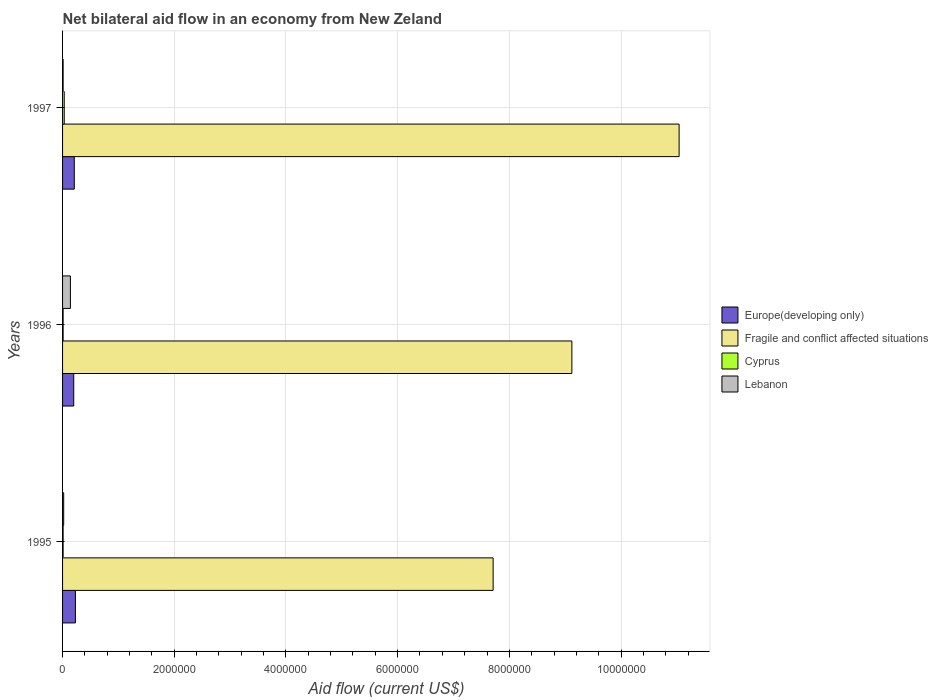How many different coloured bars are there?
Offer a very short reply. 4. Are the number of bars per tick equal to the number of legend labels?
Provide a succinct answer. Yes. Are the number of bars on each tick of the Y-axis equal?
Offer a terse response. Yes. How many bars are there on the 2nd tick from the bottom?
Your answer should be compact. 4. What is the label of the 3rd group of bars from the top?
Keep it short and to the point. 1995. Across all years, what is the maximum net bilateral aid flow in Lebanon?
Offer a very short reply. 1.40e+05. Across all years, what is the minimum net bilateral aid flow in Europe(developing only)?
Your answer should be very brief. 2.00e+05. In which year was the net bilateral aid flow in Europe(developing only) minimum?
Give a very brief answer. 1996. What is the total net bilateral aid flow in Europe(developing only) in the graph?
Your answer should be very brief. 6.40e+05. What is the difference between the net bilateral aid flow in Fragile and conflict affected situations in 1995 and that in 1996?
Provide a short and direct response. -1.41e+06. What is the difference between the net bilateral aid flow in Cyprus in 1996 and the net bilateral aid flow in Fragile and conflict affected situations in 1997?
Provide a succinct answer. -1.10e+07. What is the average net bilateral aid flow in Cyprus per year?
Make the answer very short. 1.67e+04. In the year 1997, what is the difference between the net bilateral aid flow in Cyprus and net bilateral aid flow in Lebanon?
Your answer should be very brief. 2.00e+04. What is the ratio of the net bilateral aid flow in Cyprus in 1995 to that in 1996?
Your answer should be compact. 1. Is the difference between the net bilateral aid flow in Cyprus in 1995 and 1996 greater than the difference between the net bilateral aid flow in Lebanon in 1995 and 1996?
Keep it short and to the point. Yes. What is the difference between the highest and the lowest net bilateral aid flow in Lebanon?
Offer a terse response. 1.30e+05. Is the sum of the net bilateral aid flow in Cyprus in 1996 and 1997 greater than the maximum net bilateral aid flow in Fragile and conflict affected situations across all years?
Your answer should be compact. No. Is it the case that in every year, the sum of the net bilateral aid flow in Lebanon and net bilateral aid flow in Europe(developing only) is greater than the sum of net bilateral aid flow in Cyprus and net bilateral aid flow in Fragile and conflict affected situations?
Your answer should be compact. Yes. What does the 2nd bar from the top in 1995 represents?
Your answer should be very brief. Cyprus. What does the 1st bar from the bottom in 1995 represents?
Provide a succinct answer. Europe(developing only). How many years are there in the graph?
Provide a short and direct response. 3. What is the difference between two consecutive major ticks on the X-axis?
Your response must be concise. 2.00e+06. Does the graph contain any zero values?
Your answer should be very brief. No. How are the legend labels stacked?
Offer a terse response. Vertical. What is the title of the graph?
Keep it short and to the point. Net bilateral aid flow in an economy from New Zeland. What is the label or title of the Y-axis?
Provide a short and direct response. Years. What is the Aid flow (current US$) of Fragile and conflict affected situations in 1995?
Keep it short and to the point. 7.71e+06. What is the Aid flow (current US$) in Lebanon in 1995?
Ensure brevity in your answer.  2.00e+04. What is the Aid flow (current US$) of Europe(developing only) in 1996?
Make the answer very short. 2.00e+05. What is the Aid flow (current US$) of Fragile and conflict affected situations in 1996?
Your answer should be compact. 9.12e+06. What is the Aid flow (current US$) of Fragile and conflict affected situations in 1997?
Your response must be concise. 1.10e+07. What is the Aid flow (current US$) in Lebanon in 1997?
Offer a terse response. 10000. Across all years, what is the maximum Aid flow (current US$) of Europe(developing only)?
Give a very brief answer. 2.30e+05. Across all years, what is the maximum Aid flow (current US$) in Fragile and conflict affected situations?
Offer a terse response. 1.10e+07. Across all years, what is the maximum Aid flow (current US$) of Lebanon?
Give a very brief answer. 1.40e+05. Across all years, what is the minimum Aid flow (current US$) of Fragile and conflict affected situations?
Provide a succinct answer. 7.71e+06. Across all years, what is the minimum Aid flow (current US$) in Cyprus?
Offer a very short reply. 10000. What is the total Aid flow (current US$) of Europe(developing only) in the graph?
Keep it short and to the point. 6.40e+05. What is the total Aid flow (current US$) of Fragile and conflict affected situations in the graph?
Your answer should be compact. 2.79e+07. What is the total Aid flow (current US$) in Cyprus in the graph?
Ensure brevity in your answer.  5.00e+04. What is the total Aid flow (current US$) in Lebanon in the graph?
Your answer should be compact. 1.70e+05. What is the difference between the Aid flow (current US$) in Fragile and conflict affected situations in 1995 and that in 1996?
Provide a succinct answer. -1.41e+06. What is the difference between the Aid flow (current US$) in Europe(developing only) in 1995 and that in 1997?
Your answer should be very brief. 2.00e+04. What is the difference between the Aid flow (current US$) in Fragile and conflict affected situations in 1995 and that in 1997?
Provide a succinct answer. -3.33e+06. What is the difference between the Aid flow (current US$) in Cyprus in 1995 and that in 1997?
Make the answer very short. -2.00e+04. What is the difference between the Aid flow (current US$) of Europe(developing only) in 1996 and that in 1997?
Keep it short and to the point. -10000. What is the difference between the Aid flow (current US$) of Fragile and conflict affected situations in 1996 and that in 1997?
Provide a succinct answer. -1.92e+06. What is the difference between the Aid flow (current US$) of Cyprus in 1996 and that in 1997?
Provide a short and direct response. -2.00e+04. What is the difference between the Aid flow (current US$) of Europe(developing only) in 1995 and the Aid flow (current US$) of Fragile and conflict affected situations in 1996?
Provide a succinct answer. -8.89e+06. What is the difference between the Aid flow (current US$) in Europe(developing only) in 1995 and the Aid flow (current US$) in Cyprus in 1996?
Give a very brief answer. 2.20e+05. What is the difference between the Aid flow (current US$) of Fragile and conflict affected situations in 1995 and the Aid flow (current US$) of Cyprus in 1996?
Ensure brevity in your answer.  7.70e+06. What is the difference between the Aid flow (current US$) in Fragile and conflict affected situations in 1995 and the Aid flow (current US$) in Lebanon in 1996?
Your answer should be compact. 7.57e+06. What is the difference between the Aid flow (current US$) of Europe(developing only) in 1995 and the Aid flow (current US$) of Fragile and conflict affected situations in 1997?
Give a very brief answer. -1.08e+07. What is the difference between the Aid flow (current US$) of Europe(developing only) in 1995 and the Aid flow (current US$) of Cyprus in 1997?
Your response must be concise. 2.00e+05. What is the difference between the Aid flow (current US$) of Fragile and conflict affected situations in 1995 and the Aid flow (current US$) of Cyprus in 1997?
Offer a terse response. 7.68e+06. What is the difference between the Aid flow (current US$) in Fragile and conflict affected situations in 1995 and the Aid flow (current US$) in Lebanon in 1997?
Your response must be concise. 7.70e+06. What is the difference between the Aid flow (current US$) in Cyprus in 1995 and the Aid flow (current US$) in Lebanon in 1997?
Offer a terse response. 0. What is the difference between the Aid flow (current US$) in Europe(developing only) in 1996 and the Aid flow (current US$) in Fragile and conflict affected situations in 1997?
Make the answer very short. -1.08e+07. What is the difference between the Aid flow (current US$) of Europe(developing only) in 1996 and the Aid flow (current US$) of Cyprus in 1997?
Keep it short and to the point. 1.70e+05. What is the difference between the Aid flow (current US$) of Europe(developing only) in 1996 and the Aid flow (current US$) of Lebanon in 1997?
Make the answer very short. 1.90e+05. What is the difference between the Aid flow (current US$) of Fragile and conflict affected situations in 1996 and the Aid flow (current US$) of Cyprus in 1997?
Your response must be concise. 9.09e+06. What is the difference between the Aid flow (current US$) in Fragile and conflict affected situations in 1996 and the Aid flow (current US$) in Lebanon in 1997?
Keep it short and to the point. 9.11e+06. What is the average Aid flow (current US$) in Europe(developing only) per year?
Your answer should be very brief. 2.13e+05. What is the average Aid flow (current US$) of Fragile and conflict affected situations per year?
Provide a succinct answer. 9.29e+06. What is the average Aid flow (current US$) in Cyprus per year?
Ensure brevity in your answer.  1.67e+04. What is the average Aid flow (current US$) of Lebanon per year?
Make the answer very short. 5.67e+04. In the year 1995, what is the difference between the Aid flow (current US$) in Europe(developing only) and Aid flow (current US$) in Fragile and conflict affected situations?
Provide a succinct answer. -7.48e+06. In the year 1995, what is the difference between the Aid flow (current US$) in Fragile and conflict affected situations and Aid flow (current US$) in Cyprus?
Offer a very short reply. 7.70e+06. In the year 1995, what is the difference between the Aid flow (current US$) of Fragile and conflict affected situations and Aid flow (current US$) of Lebanon?
Your answer should be compact. 7.69e+06. In the year 1995, what is the difference between the Aid flow (current US$) in Cyprus and Aid flow (current US$) in Lebanon?
Make the answer very short. -10000. In the year 1996, what is the difference between the Aid flow (current US$) in Europe(developing only) and Aid flow (current US$) in Fragile and conflict affected situations?
Provide a short and direct response. -8.92e+06. In the year 1996, what is the difference between the Aid flow (current US$) in Europe(developing only) and Aid flow (current US$) in Cyprus?
Give a very brief answer. 1.90e+05. In the year 1996, what is the difference between the Aid flow (current US$) of Fragile and conflict affected situations and Aid flow (current US$) of Cyprus?
Provide a succinct answer. 9.11e+06. In the year 1996, what is the difference between the Aid flow (current US$) in Fragile and conflict affected situations and Aid flow (current US$) in Lebanon?
Offer a very short reply. 8.98e+06. In the year 1996, what is the difference between the Aid flow (current US$) in Cyprus and Aid flow (current US$) in Lebanon?
Offer a terse response. -1.30e+05. In the year 1997, what is the difference between the Aid flow (current US$) of Europe(developing only) and Aid flow (current US$) of Fragile and conflict affected situations?
Ensure brevity in your answer.  -1.08e+07. In the year 1997, what is the difference between the Aid flow (current US$) in Fragile and conflict affected situations and Aid flow (current US$) in Cyprus?
Offer a very short reply. 1.10e+07. In the year 1997, what is the difference between the Aid flow (current US$) of Fragile and conflict affected situations and Aid flow (current US$) of Lebanon?
Provide a short and direct response. 1.10e+07. What is the ratio of the Aid flow (current US$) in Europe(developing only) in 1995 to that in 1996?
Your answer should be compact. 1.15. What is the ratio of the Aid flow (current US$) of Fragile and conflict affected situations in 1995 to that in 1996?
Offer a very short reply. 0.85. What is the ratio of the Aid flow (current US$) in Lebanon in 1995 to that in 1996?
Make the answer very short. 0.14. What is the ratio of the Aid flow (current US$) in Europe(developing only) in 1995 to that in 1997?
Your answer should be very brief. 1.1. What is the ratio of the Aid flow (current US$) of Fragile and conflict affected situations in 1995 to that in 1997?
Ensure brevity in your answer.  0.7. What is the ratio of the Aid flow (current US$) of Lebanon in 1995 to that in 1997?
Offer a very short reply. 2. What is the ratio of the Aid flow (current US$) of Fragile and conflict affected situations in 1996 to that in 1997?
Give a very brief answer. 0.83. What is the ratio of the Aid flow (current US$) of Cyprus in 1996 to that in 1997?
Keep it short and to the point. 0.33. What is the difference between the highest and the second highest Aid flow (current US$) in Fragile and conflict affected situations?
Your answer should be compact. 1.92e+06. What is the difference between the highest and the second highest Aid flow (current US$) in Cyprus?
Your response must be concise. 2.00e+04. What is the difference between the highest and the lowest Aid flow (current US$) in Europe(developing only)?
Your response must be concise. 3.00e+04. What is the difference between the highest and the lowest Aid flow (current US$) of Fragile and conflict affected situations?
Ensure brevity in your answer.  3.33e+06. What is the difference between the highest and the lowest Aid flow (current US$) of Cyprus?
Your response must be concise. 2.00e+04. What is the difference between the highest and the lowest Aid flow (current US$) in Lebanon?
Make the answer very short. 1.30e+05. 